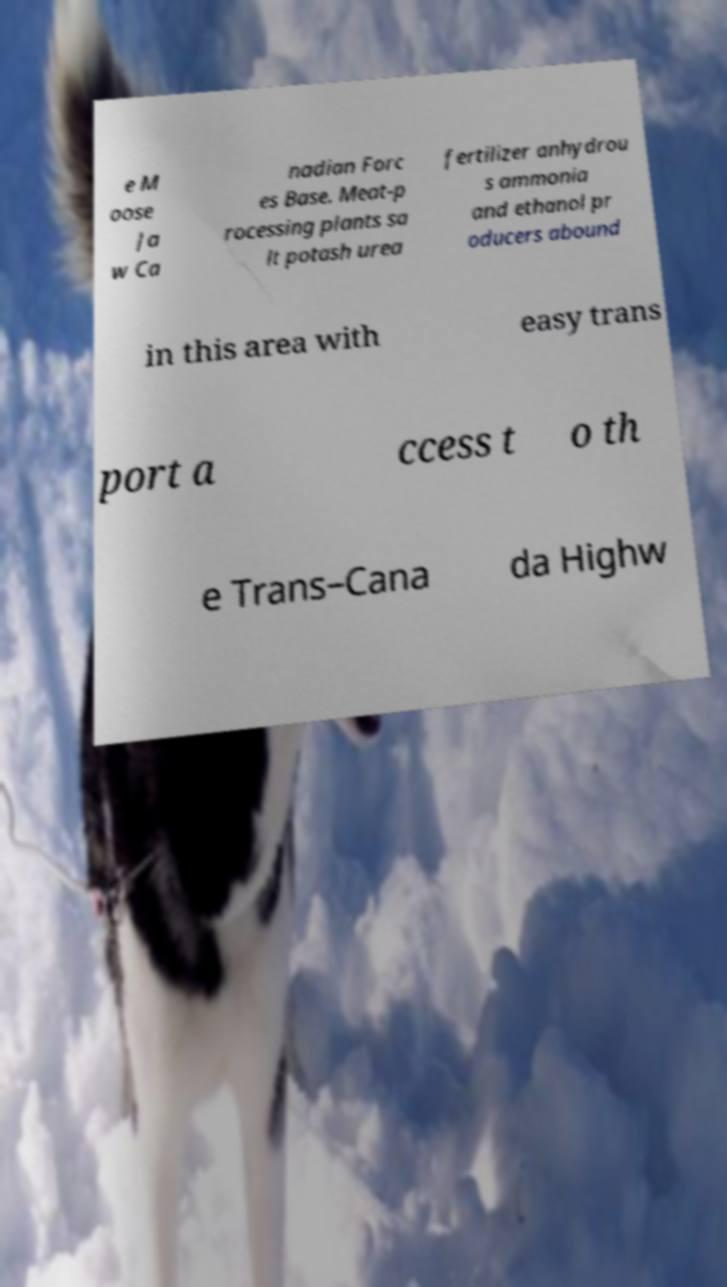Could you extract and type out the text from this image? e M oose Ja w Ca nadian Forc es Base. Meat-p rocessing plants sa lt potash urea fertilizer anhydrou s ammonia and ethanol pr oducers abound in this area with easy trans port a ccess t o th e Trans–Cana da Highw 